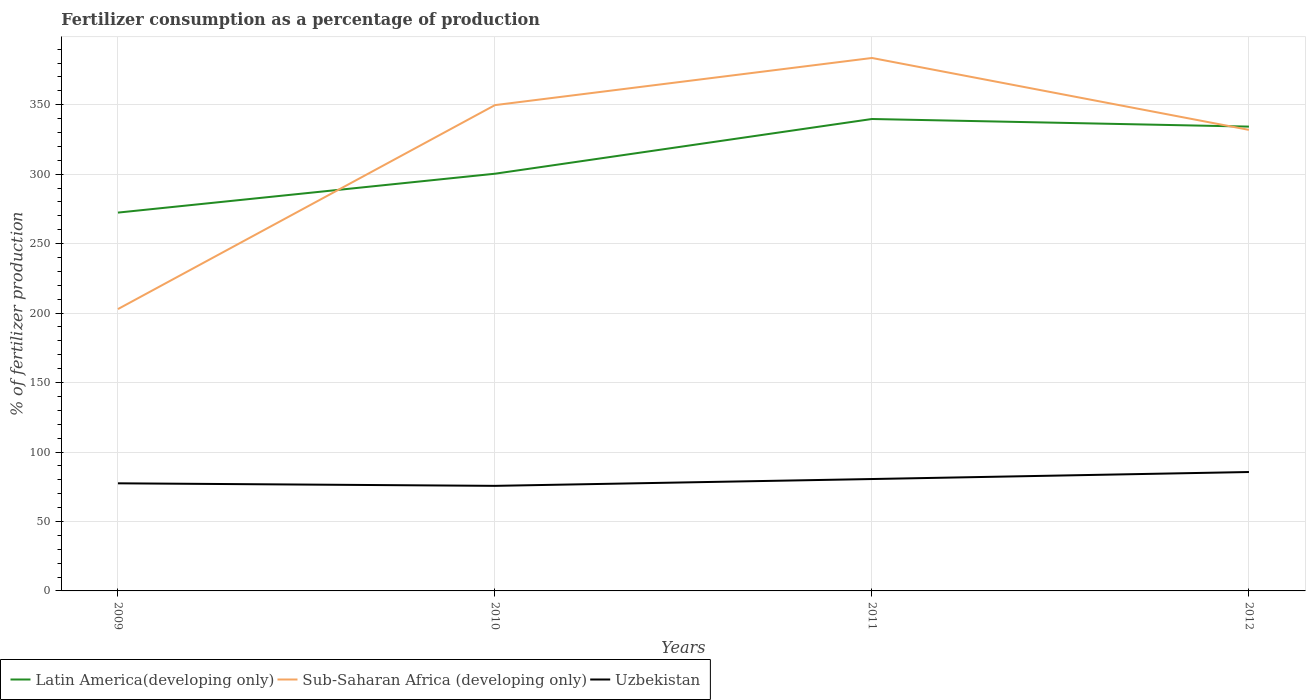Does the line corresponding to Sub-Saharan Africa (developing only) intersect with the line corresponding to Uzbekistan?
Your response must be concise. No. Across all years, what is the maximum percentage of fertilizers consumed in Sub-Saharan Africa (developing only)?
Keep it short and to the point. 202.91. In which year was the percentage of fertilizers consumed in Uzbekistan maximum?
Give a very brief answer. 2010. What is the total percentage of fertilizers consumed in Latin America(developing only) in the graph?
Your response must be concise. -33.91. What is the difference between the highest and the second highest percentage of fertilizers consumed in Sub-Saharan Africa (developing only)?
Your answer should be compact. 180.77. What is the difference between the highest and the lowest percentage of fertilizers consumed in Latin America(developing only)?
Offer a terse response. 2. How many lines are there?
Make the answer very short. 3. How many years are there in the graph?
Give a very brief answer. 4. Are the values on the major ticks of Y-axis written in scientific E-notation?
Make the answer very short. No. How are the legend labels stacked?
Offer a terse response. Horizontal. What is the title of the graph?
Your answer should be very brief. Fertilizer consumption as a percentage of production. Does "Maldives" appear as one of the legend labels in the graph?
Provide a short and direct response. No. What is the label or title of the X-axis?
Give a very brief answer. Years. What is the label or title of the Y-axis?
Make the answer very short. % of fertilizer production. What is the % of fertilizer production of Latin America(developing only) in 2009?
Provide a succinct answer. 272.35. What is the % of fertilizer production of Sub-Saharan Africa (developing only) in 2009?
Offer a terse response. 202.91. What is the % of fertilizer production of Uzbekistan in 2009?
Your response must be concise. 77.46. What is the % of fertilizer production of Latin America(developing only) in 2010?
Provide a short and direct response. 300.35. What is the % of fertilizer production in Sub-Saharan Africa (developing only) in 2010?
Make the answer very short. 349.74. What is the % of fertilizer production of Uzbekistan in 2010?
Provide a succinct answer. 75.64. What is the % of fertilizer production of Latin America(developing only) in 2011?
Keep it short and to the point. 339.75. What is the % of fertilizer production of Sub-Saharan Africa (developing only) in 2011?
Ensure brevity in your answer.  383.68. What is the % of fertilizer production of Uzbekistan in 2011?
Your answer should be very brief. 80.55. What is the % of fertilizer production in Latin America(developing only) in 2012?
Offer a terse response. 334.26. What is the % of fertilizer production in Sub-Saharan Africa (developing only) in 2012?
Keep it short and to the point. 331.91. What is the % of fertilizer production of Uzbekistan in 2012?
Ensure brevity in your answer.  85.6. Across all years, what is the maximum % of fertilizer production of Latin America(developing only)?
Your answer should be compact. 339.75. Across all years, what is the maximum % of fertilizer production of Sub-Saharan Africa (developing only)?
Provide a short and direct response. 383.68. Across all years, what is the maximum % of fertilizer production of Uzbekistan?
Give a very brief answer. 85.6. Across all years, what is the minimum % of fertilizer production of Latin America(developing only)?
Your response must be concise. 272.35. Across all years, what is the minimum % of fertilizer production in Sub-Saharan Africa (developing only)?
Your answer should be very brief. 202.91. Across all years, what is the minimum % of fertilizer production in Uzbekistan?
Your response must be concise. 75.64. What is the total % of fertilizer production in Latin America(developing only) in the graph?
Your response must be concise. 1246.71. What is the total % of fertilizer production of Sub-Saharan Africa (developing only) in the graph?
Make the answer very short. 1268.23. What is the total % of fertilizer production in Uzbekistan in the graph?
Provide a succinct answer. 319.26. What is the difference between the % of fertilizer production in Latin America(developing only) in 2009 and that in 2010?
Keep it short and to the point. -28. What is the difference between the % of fertilizer production of Sub-Saharan Africa (developing only) in 2009 and that in 2010?
Give a very brief answer. -146.83. What is the difference between the % of fertilizer production in Uzbekistan in 2009 and that in 2010?
Your response must be concise. 1.82. What is the difference between the % of fertilizer production in Latin America(developing only) in 2009 and that in 2011?
Your answer should be very brief. -67.39. What is the difference between the % of fertilizer production of Sub-Saharan Africa (developing only) in 2009 and that in 2011?
Make the answer very short. -180.77. What is the difference between the % of fertilizer production in Uzbekistan in 2009 and that in 2011?
Offer a very short reply. -3.09. What is the difference between the % of fertilizer production in Latin America(developing only) in 2009 and that in 2012?
Provide a succinct answer. -61.91. What is the difference between the % of fertilizer production in Sub-Saharan Africa (developing only) in 2009 and that in 2012?
Offer a terse response. -129. What is the difference between the % of fertilizer production in Uzbekistan in 2009 and that in 2012?
Offer a terse response. -8.14. What is the difference between the % of fertilizer production of Latin America(developing only) in 2010 and that in 2011?
Offer a terse response. -39.4. What is the difference between the % of fertilizer production in Sub-Saharan Africa (developing only) in 2010 and that in 2011?
Make the answer very short. -33.94. What is the difference between the % of fertilizer production in Uzbekistan in 2010 and that in 2011?
Offer a very short reply. -4.91. What is the difference between the % of fertilizer production in Latin America(developing only) in 2010 and that in 2012?
Your answer should be compact. -33.91. What is the difference between the % of fertilizer production in Sub-Saharan Africa (developing only) in 2010 and that in 2012?
Offer a very short reply. 17.83. What is the difference between the % of fertilizer production of Uzbekistan in 2010 and that in 2012?
Provide a succinct answer. -9.96. What is the difference between the % of fertilizer production of Latin America(developing only) in 2011 and that in 2012?
Your answer should be compact. 5.49. What is the difference between the % of fertilizer production in Sub-Saharan Africa (developing only) in 2011 and that in 2012?
Provide a short and direct response. 51.77. What is the difference between the % of fertilizer production of Uzbekistan in 2011 and that in 2012?
Make the answer very short. -5.05. What is the difference between the % of fertilizer production of Latin America(developing only) in 2009 and the % of fertilizer production of Sub-Saharan Africa (developing only) in 2010?
Your response must be concise. -77.38. What is the difference between the % of fertilizer production of Latin America(developing only) in 2009 and the % of fertilizer production of Uzbekistan in 2010?
Keep it short and to the point. 196.71. What is the difference between the % of fertilizer production in Sub-Saharan Africa (developing only) in 2009 and the % of fertilizer production in Uzbekistan in 2010?
Offer a terse response. 127.27. What is the difference between the % of fertilizer production of Latin America(developing only) in 2009 and the % of fertilizer production of Sub-Saharan Africa (developing only) in 2011?
Your response must be concise. -111.32. What is the difference between the % of fertilizer production in Latin America(developing only) in 2009 and the % of fertilizer production in Uzbekistan in 2011?
Provide a succinct answer. 191.8. What is the difference between the % of fertilizer production of Sub-Saharan Africa (developing only) in 2009 and the % of fertilizer production of Uzbekistan in 2011?
Offer a very short reply. 122.36. What is the difference between the % of fertilizer production of Latin America(developing only) in 2009 and the % of fertilizer production of Sub-Saharan Africa (developing only) in 2012?
Your answer should be compact. -59.55. What is the difference between the % of fertilizer production in Latin America(developing only) in 2009 and the % of fertilizer production in Uzbekistan in 2012?
Provide a succinct answer. 186.75. What is the difference between the % of fertilizer production in Sub-Saharan Africa (developing only) in 2009 and the % of fertilizer production in Uzbekistan in 2012?
Your answer should be very brief. 117.3. What is the difference between the % of fertilizer production of Latin America(developing only) in 2010 and the % of fertilizer production of Sub-Saharan Africa (developing only) in 2011?
Give a very brief answer. -83.33. What is the difference between the % of fertilizer production of Latin America(developing only) in 2010 and the % of fertilizer production of Uzbekistan in 2011?
Make the answer very short. 219.8. What is the difference between the % of fertilizer production of Sub-Saharan Africa (developing only) in 2010 and the % of fertilizer production of Uzbekistan in 2011?
Your response must be concise. 269.19. What is the difference between the % of fertilizer production of Latin America(developing only) in 2010 and the % of fertilizer production of Sub-Saharan Africa (developing only) in 2012?
Your answer should be compact. -31.56. What is the difference between the % of fertilizer production in Latin America(developing only) in 2010 and the % of fertilizer production in Uzbekistan in 2012?
Your answer should be compact. 214.74. What is the difference between the % of fertilizer production in Sub-Saharan Africa (developing only) in 2010 and the % of fertilizer production in Uzbekistan in 2012?
Your answer should be very brief. 264.13. What is the difference between the % of fertilizer production of Latin America(developing only) in 2011 and the % of fertilizer production of Sub-Saharan Africa (developing only) in 2012?
Provide a short and direct response. 7.84. What is the difference between the % of fertilizer production in Latin America(developing only) in 2011 and the % of fertilizer production in Uzbekistan in 2012?
Ensure brevity in your answer.  254.14. What is the difference between the % of fertilizer production in Sub-Saharan Africa (developing only) in 2011 and the % of fertilizer production in Uzbekistan in 2012?
Offer a very short reply. 298.07. What is the average % of fertilizer production in Latin America(developing only) per year?
Give a very brief answer. 311.68. What is the average % of fertilizer production of Sub-Saharan Africa (developing only) per year?
Provide a short and direct response. 317.06. What is the average % of fertilizer production of Uzbekistan per year?
Your answer should be compact. 79.82. In the year 2009, what is the difference between the % of fertilizer production of Latin America(developing only) and % of fertilizer production of Sub-Saharan Africa (developing only)?
Your answer should be very brief. 69.45. In the year 2009, what is the difference between the % of fertilizer production of Latin America(developing only) and % of fertilizer production of Uzbekistan?
Provide a succinct answer. 194.89. In the year 2009, what is the difference between the % of fertilizer production of Sub-Saharan Africa (developing only) and % of fertilizer production of Uzbekistan?
Give a very brief answer. 125.44. In the year 2010, what is the difference between the % of fertilizer production in Latin America(developing only) and % of fertilizer production in Sub-Saharan Africa (developing only)?
Make the answer very short. -49.39. In the year 2010, what is the difference between the % of fertilizer production of Latin America(developing only) and % of fertilizer production of Uzbekistan?
Provide a succinct answer. 224.71. In the year 2010, what is the difference between the % of fertilizer production in Sub-Saharan Africa (developing only) and % of fertilizer production in Uzbekistan?
Your answer should be very brief. 274.1. In the year 2011, what is the difference between the % of fertilizer production in Latin America(developing only) and % of fertilizer production in Sub-Saharan Africa (developing only)?
Your answer should be compact. -43.93. In the year 2011, what is the difference between the % of fertilizer production in Latin America(developing only) and % of fertilizer production in Uzbekistan?
Give a very brief answer. 259.19. In the year 2011, what is the difference between the % of fertilizer production in Sub-Saharan Africa (developing only) and % of fertilizer production in Uzbekistan?
Provide a succinct answer. 303.13. In the year 2012, what is the difference between the % of fertilizer production of Latin America(developing only) and % of fertilizer production of Sub-Saharan Africa (developing only)?
Provide a succinct answer. 2.35. In the year 2012, what is the difference between the % of fertilizer production in Latin America(developing only) and % of fertilizer production in Uzbekistan?
Your response must be concise. 248.66. In the year 2012, what is the difference between the % of fertilizer production of Sub-Saharan Africa (developing only) and % of fertilizer production of Uzbekistan?
Provide a succinct answer. 246.3. What is the ratio of the % of fertilizer production of Latin America(developing only) in 2009 to that in 2010?
Provide a short and direct response. 0.91. What is the ratio of the % of fertilizer production of Sub-Saharan Africa (developing only) in 2009 to that in 2010?
Your response must be concise. 0.58. What is the ratio of the % of fertilizer production in Uzbekistan in 2009 to that in 2010?
Give a very brief answer. 1.02. What is the ratio of the % of fertilizer production in Latin America(developing only) in 2009 to that in 2011?
Provide a short and direct response. 0.8. What is the ratio of the % of fertilizer production in Sub-Saharan Africa (developing only) in 2009 to that in 2011?
Your response must be concise. 0.53. What is the ratio of the % of fertilizer production in Uzbekistan in 2009 to that in 2011?
Make the answer very short. 0.96. What is the ratio of the % of fertilizer production of Latin America(developing only) in 2009 to that in 2012?
Offer a very short reply. 0.81. What is the ratio of the % of fertilizer production in Sub-Saharan Africa (developing only) in 2009 to that in 2012?
Keep it short and to the point. 0.61. What is the ratio of the % of fertilizer production of Uzbekistan in 2009 to that in 2012?
Ensure brevity in your answer.  0.9. What is the ratio of the % of fertilizer production in Latin America(developing only) in 2010 to that in 2011?
Keep it short and to the point. 0.88. What is the ratio of the % of fertilizer production in Sub-Saharan Africa (developing only) in 2010 to that in 2011?
Ensure brevity in your answer.  0.91. What is the ratio of the % of fertilizer production of Uzbekistan in 2010 to that in 2011?
Keep it short and to the point. 0.94. What is the ratio of the % of fertilizer production of Latin America(developing only) in 2010 to that in 2012?
Your response must be concise. 0.9. What is the ratio of the % of fertilizer production of Sub-Saharan Africa (developing only) in 2010 to that in 2012?
Offer a very short reply. 1.05. What is the ratio of the % of fertilizer production in Uzbekistan in 2010 to that in 2012?
Make the answer very short. 0.88. What is the ratio of the % of fertilizer production in Latin America(developing only) in 2011 to that in 2012?
Offer a terse response. 1.02. What is the ratio of the % of fertilizer production of Sub-Saharan Africa (developing only) in 2011 to that in 2012?
Ensure brevity in your answer.  1.16. What is the ratio of the % of fertilizer production of Uzbekistan in 2011 to that in 2012?
Provide a succinct answer. 0.94. What is the difference between the highest and the second highest % of fertilizer production in Latin America(developing only)?
Ensure brevity in your answer.  5.49. What is the difference between the highest and the second highest % of fertilizer production of Sub-Saharan Africa (developing only)?
Your answer should be compact. 33.94. What is the difference between the highest and the second highest % of fertilizer production of Uzbekistan?
Offer a very short reply. 5.05. What is the difference between the highest and the lowest % of fertilizer production in Latin America(developing only)?
Give a very brief answer. 67.39. What is the difference between the highest and the lowest % of fertilizer production of Sub-Saharan Africa (developing only)?
Provide a short and direct response. 180.77. What is the difference between the highest and the lowest % of fertilizer production of Uzbekistan?
Ensure brevity in your answer.  9.96. 